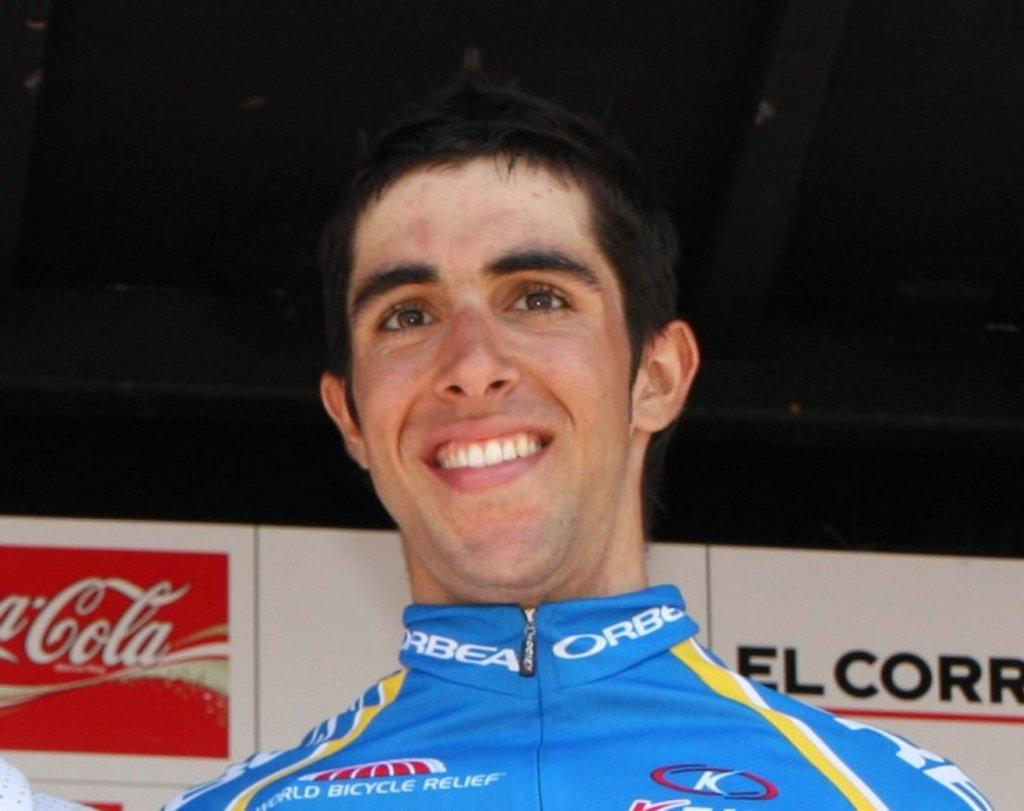<image>
Offer a succinct explanation of the picture presented. A man wearing a World Bicycle Relief shirt stands in front of a Coca-Cola sign. 